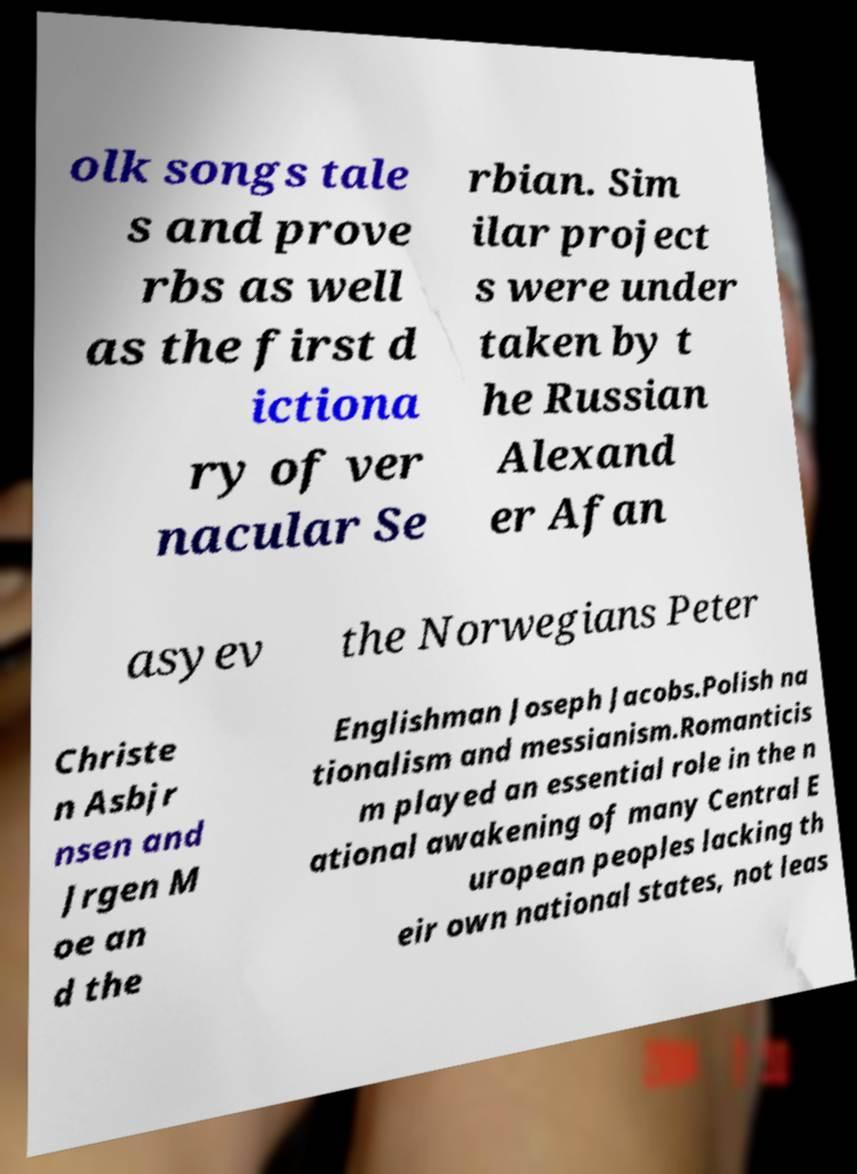Please identify and transcribe the text found in this image. olk songs tale s and prove rbs as well as the first d ictiona ry of ver nacular Se rbian. Sim ilar project s were under taken by t he Russian Alexand er Afan asyev the Norwegians Peter Christe n Asbjr nsen and Jrgen M oe an d the Englishman Joseph Jacobs.Polish na tionalism and messianism.Romanticis m played an essential role in the n ational awakening of many Central E uropean peoples lacking th eir own national states, not leas 